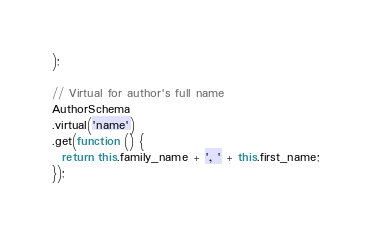<code> <loc_0><loc_0><loc_500><loc_500><_JavaScript_>);

// Virtual for author's full name
AuthorSchema
.virtual('name')
.get(function () {
  return this.family_name + ', ' + this.first_name;
});
</code> 